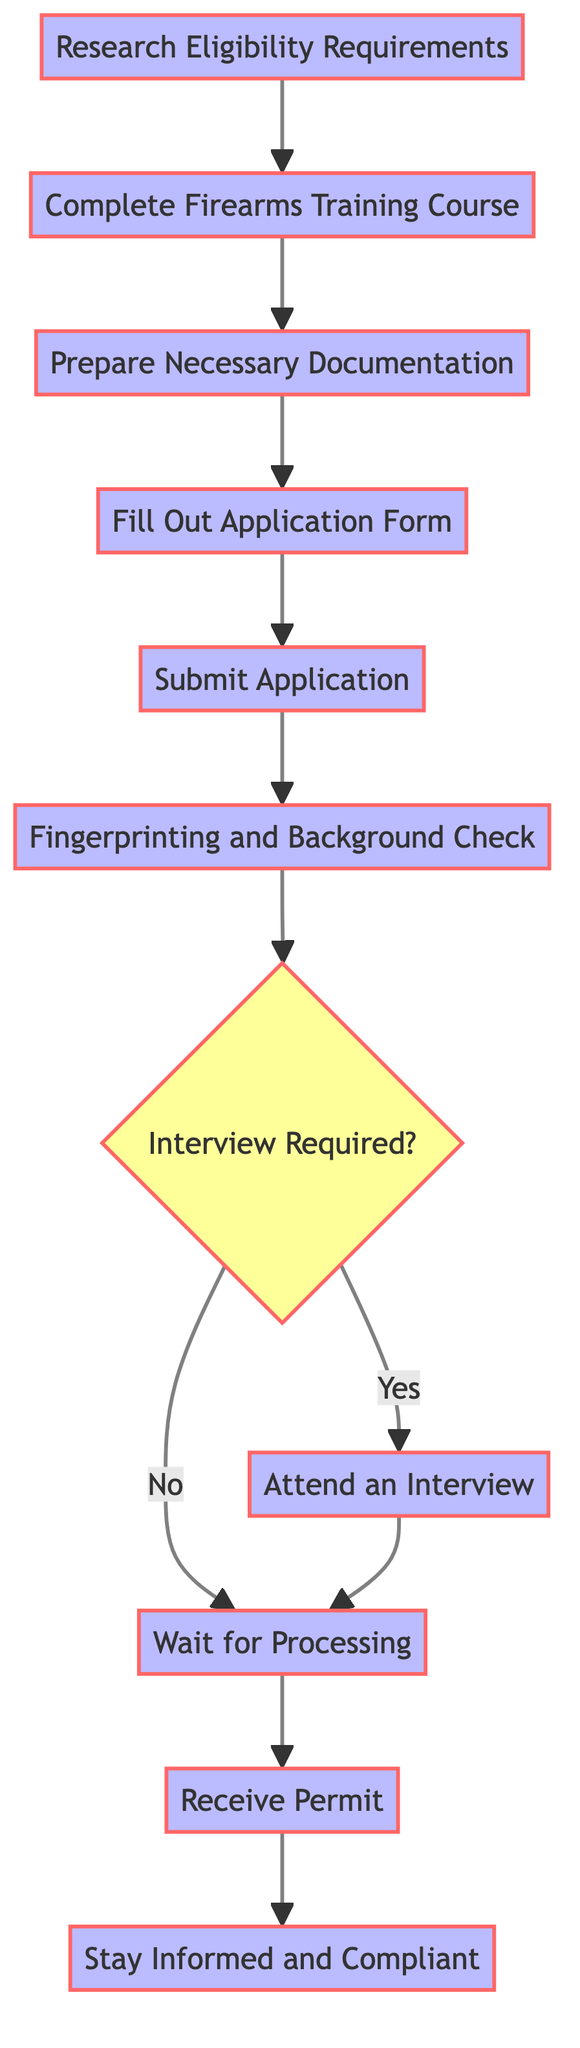What is the first step in the process? The first step displayed in the flowchart is "Research Eligibility Requirements." It is the initial node leading to the next step, indicating that understanding the eligibility for a concealed carry permit is fundamental before proceeding.
Answer: Research Eligibility Requirements What comes after "Submit Application"? After "Submit Application," the next action in the flowchart is "Fingerprinting and Background Check." This indicates that submitting the application leads directly to undergoing security measures.
Answer: Fingerprinting and Background Check How many steps are there in total? The flowchart lists a total of 10 distinct steps that guide an individual through the process of applying for a concealed carry permit, from research to receiving the permit.
Answer: 10 What are the two options after "Fingerprinting and Background Check"? After "Fingerprinting and Background Check," the flowchart presents two paths based on whether an interview is required or not, indicated by the decision node "Interview Required?"
Answer: Yes and No What is the last step in the process? The final step shown in the flowchart is "Stay Informed and Compliant," which highlights the importance of ongoing compliance with laws after obtaining the permit.
Answer: Stay Informed and Compliant If an interview is required, what step follows? If an interview is required, the flowchart indicates that the next step after the decision node is "Attend an Interview," leading to the next stage in the application process.
Answer: Attend an Interview Which step requires gathering documents? The step that involves gathering documents is "Prepare Necessary Documentation." This step specifically focuses on collecting the necessary paperwork before filling out the application.
Answer: Prepare Necessary Documentation What does the decision node "Interview Required?" indicate? The decision node "Interview Required?" indicates that there is a bifurcation in the flow of the process, leading either to "Attend an Interview" if yes, or directly to "Wait for Processing" if no.
Answer: Whether to attend an interview or not 